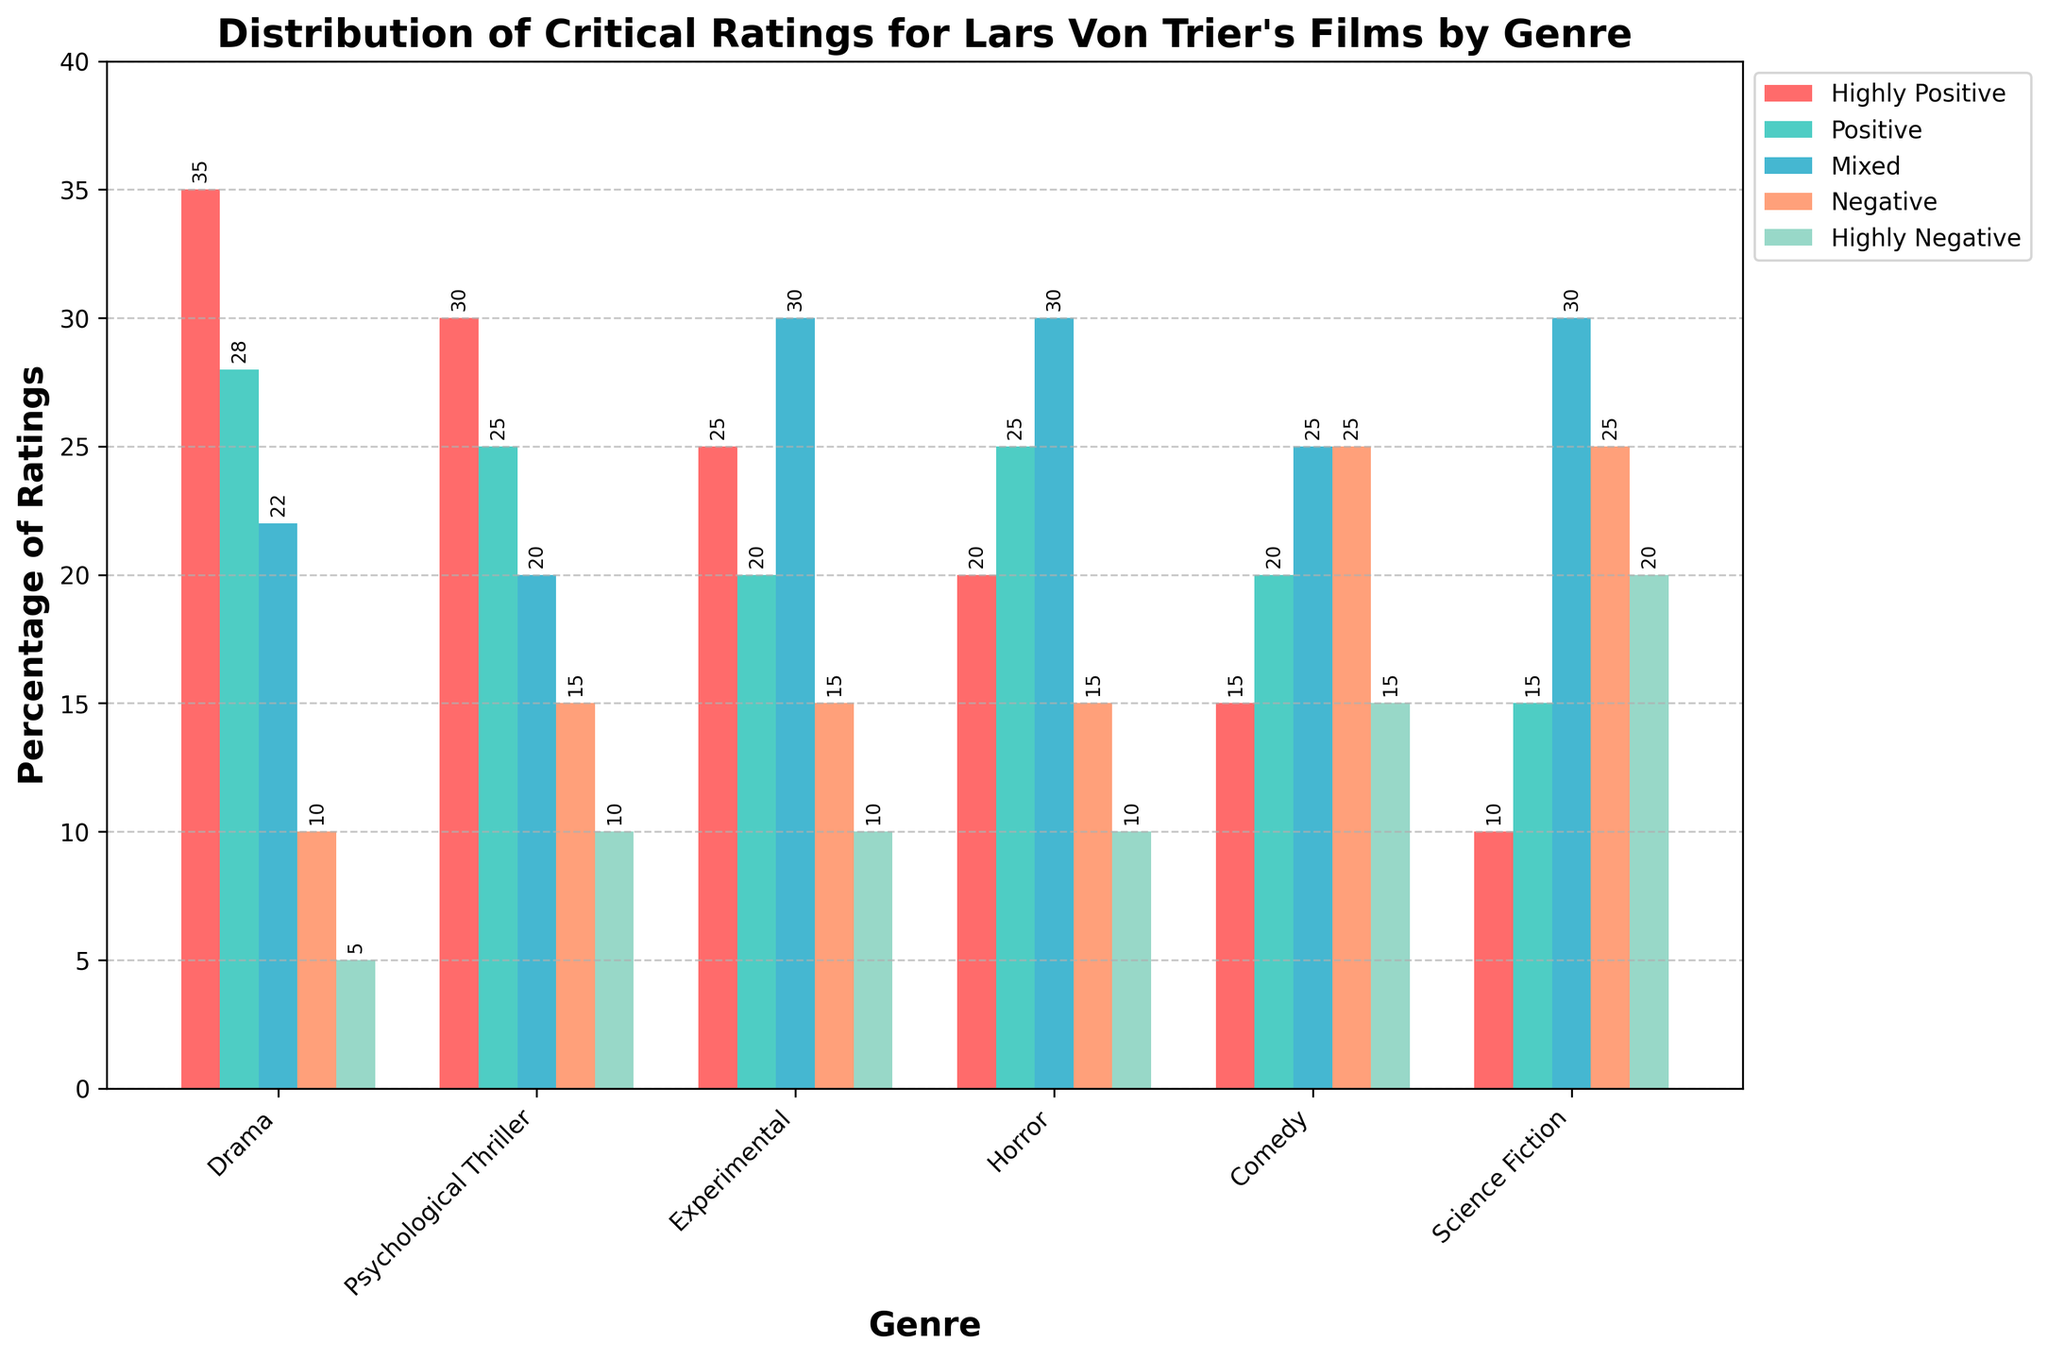Which genre has the highest percentage of Highly Positive ratings? Check each genre's Highly Positive rating bar height visually and confirm that the Drama genre's bar is the tallest.
Answer: Drama Which genre has the highest combined percentage of Highly Negative and Negative ratings? Sum the Highly Negative and Negative ratings for each genre and find the highest sum. Comedy has a total of 40% (15% Highly Negative + 25% Negative).
Answer: Comedy What is the combined percentage of Mixed ratings for Experimental and Horror genres? Add the Mixed ratings for Experimental (30%) and Horror (30%).
Answer: 60% Which genre has the lowest percentage of Positive ratings? Compare the Positive rating bars for all genres and find that Science Fiction has the lowest with 15%.
Answer: Science Fiction Across all genres, which rating category consistently has a higher percentage compared to others? Observe the trend for rating categories across all genres. The Mixed category has relatively high bars in comparison to others.
Answer: Mixed How much higher is the Highly Positive rating for Drama compared to Science Fiction? Subtract the Highly Positive rating of Science Fiction (10%) from Drama (35%).
Answer: 25% Which genre has the smallest percentage difference between Highly Positive and Highly Negative ratings? Calculate the difference between Highly Positive and Highly Negative ratings for each genre. Experimental and Horror both have a smallest difference of 15% (25% - 10%).
Answer: Horror and Experimental How do Positive ratings for Psychological Thriller compare to those of Horror? Compare the height of the Positive rating bars for Psychological Thriller (25%) and Horror (25%).
Answer: Equal What is the average percentage of Highly Positive ratings across all genres? Sum the Highly Positive ratings (35 + 30 + 25 + 20 + 15 + 10) and divide by 6.
Answer: 22.5% Which genre has a higher Negative rating: Comedy or Science Fiction? Compare the Negative ratings for Comedy (25%) and Science Fiction (25%).
Answer: Equal 